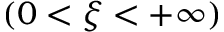Convert formula to latex. <formula><loc_0><loc_0><loc_500><loc_500>( 0 < \xi < + \infty )</formula> 